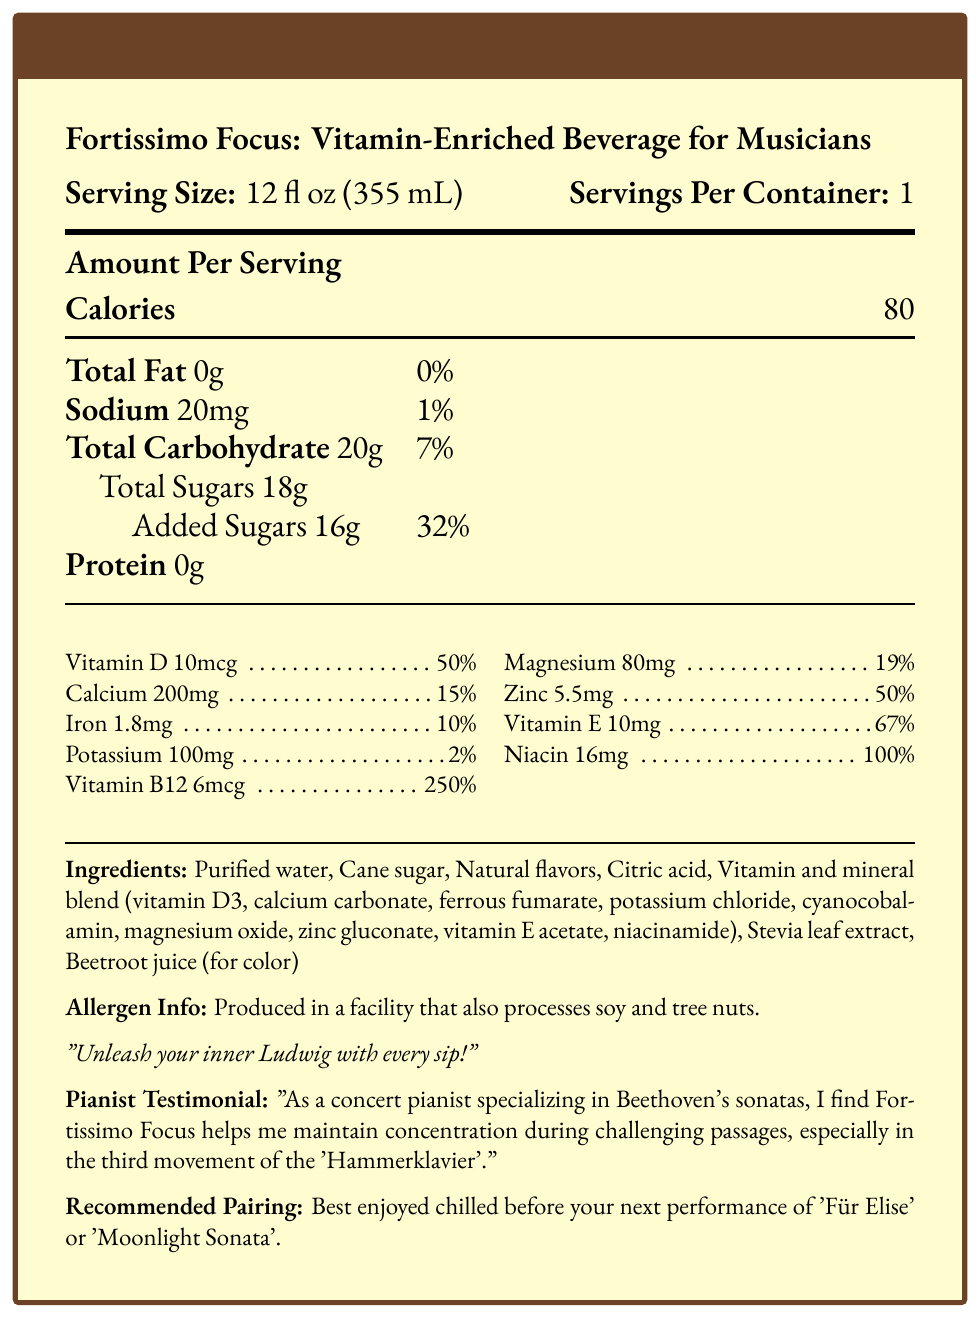what is the serving size? The serving size is explicitly stated as "12 fl oz (355 mL)" in the document.
Answer: 12 fl oz (355 mL) how many calories are in one serving of Fortissimo Focus? The document notes that there are 80 calories per serving.
Answer: 80 calories what percentage of the daily value of Vitamin B12 does one serving provide? The document lists Vitamin B12 at 250% of the daily value per serving.
Answer: 250% what are some of the main ingredients in Fortissimo Focus? The ingredients list in the document includes Purified water, Cane sugar, Natural flavors, and Citric acid among others.
Answer: Purified water, Cane sugar, Natural flavors, Citric acid how much added sugars is in the drink? The document specifies "Added Sugars 16g".
Answer: 16g does Fortissimo Focus contain any protein? The document indicates that the protein content is 0g.
Answer: No how much sodium is in one serving? The document states that sodium content per serving is 20mg.
Answer: 20mg what claim is made about the importance of magnesium in this drink? One of the marketing claims made in the document states magnesium helps reduce muscle tension.
Answer: Magnesium helps reduce muscle tension what vitamin and mineral blend ingredient provides Vitamin D? The Vitamin and mineral blend includes Vitamin D3 as the source of Vitamin D, according to the ingredients list in the document.
Answer: Vitamin D3 which performance pieces are recommended to enjoy this beverage before performing? The document recommends enjoying the beverage before performing 'Für Elise' or 'Moonlight Sonata'.
Answer: 'Für Elise' or 'Moonlight Sonata' which of the following statements is true about Fortissimo Focus? 
    A. It contains gluten
    B. It has high sodium content
    C. It contains zinc
    D. It has high protein content The document shows zinc as an ingredient and nutrient, while the other statements are not true according to the ingredients list and nutritional values.
Answer: C which vitamin supports immune function for touring musicians according to the claims in the document? 
    I. Vitamin D
    II. Vitamin E
    III. Vitamin B12
    IV. Magnesium The document claims that Zinc and Vitamin D support immune function, but Vitamin E is explicitly mentioned while Vitamin B12 and Magnesium are not.
Answer: I and II is Fortissimo Focus produced in a facility that processes soy and tree nuts? The document includes an allergen info section stating it is produced in a facility that also processes soy and tree nuts.
Answer: Yes summarize the main idea of the Fortissimo Focus Nutritional Facts document. The document provides comprehensive nutritional information, marketing claims, ingredients, and a testimonial emphasizing the drink's benefits for musicians, especially pianists.
Answer: Fortissimo Focus is a vitamin-enriched beverage aimed at classical musicians, providing key vitamins and minerals to support mental focus, physical endurance, and immune function. It contains ingredients like purified water, cane sugar, and natural flavors. Key nutrients include Vitamin B12, magnesium, Vitamin D, and zinc. It also has low sodium to maintain vocal health and is free of protein and fat. how does the nutritional information relate to the marketing claims? Explanation: The document provides specific daily values for vitamins and minerals that correlate with the claims about mental focus, physical endurance, and immune function.
Answer: The nutritional information supports the marketing claims by listing high percentages of nutrients like Vitamin B12 (250%), magnesium (19%), and others purported to support focus and reduce muscle tension. does the drink contain artificial sweeteners? The document lists cane sugar and stevia leaf extract but does not specify whether these are considered artificial sweeteners or not.
Answer: Not clear how many grams of total carbohydrates does the drink contain? The document clearly states that the total carbohydrate content is 20g per serving.
Answer: 20g what is the tagline that relates to Beethoven? The tagline mentioned in the document is "Unleash your inner Ludwig with every sip!"
Answer: "Unleash your inner Ludwig with every sip!" what benefit does Vitamin E in the drink provide according to its daily value percentage? The document indicates that the Vitamin E content meets 67% of the recommended daily value.
Answer: Vitamin E aims to support 67% of daily needs who provided the testimonial included in the document? The testimonial in the document is given by a concert pianist who specializes in Beethoven's sonatas.
Answer: A concert pianist specializing in Beethoven's sonatas 